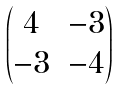Convert formula to latex. <formula><loc_0><loc_0><loc_500><loc_500>\begin{pmatrix} 4 & - 3 \\ - 3 & - 4 \end{pmatrix}</formula> 